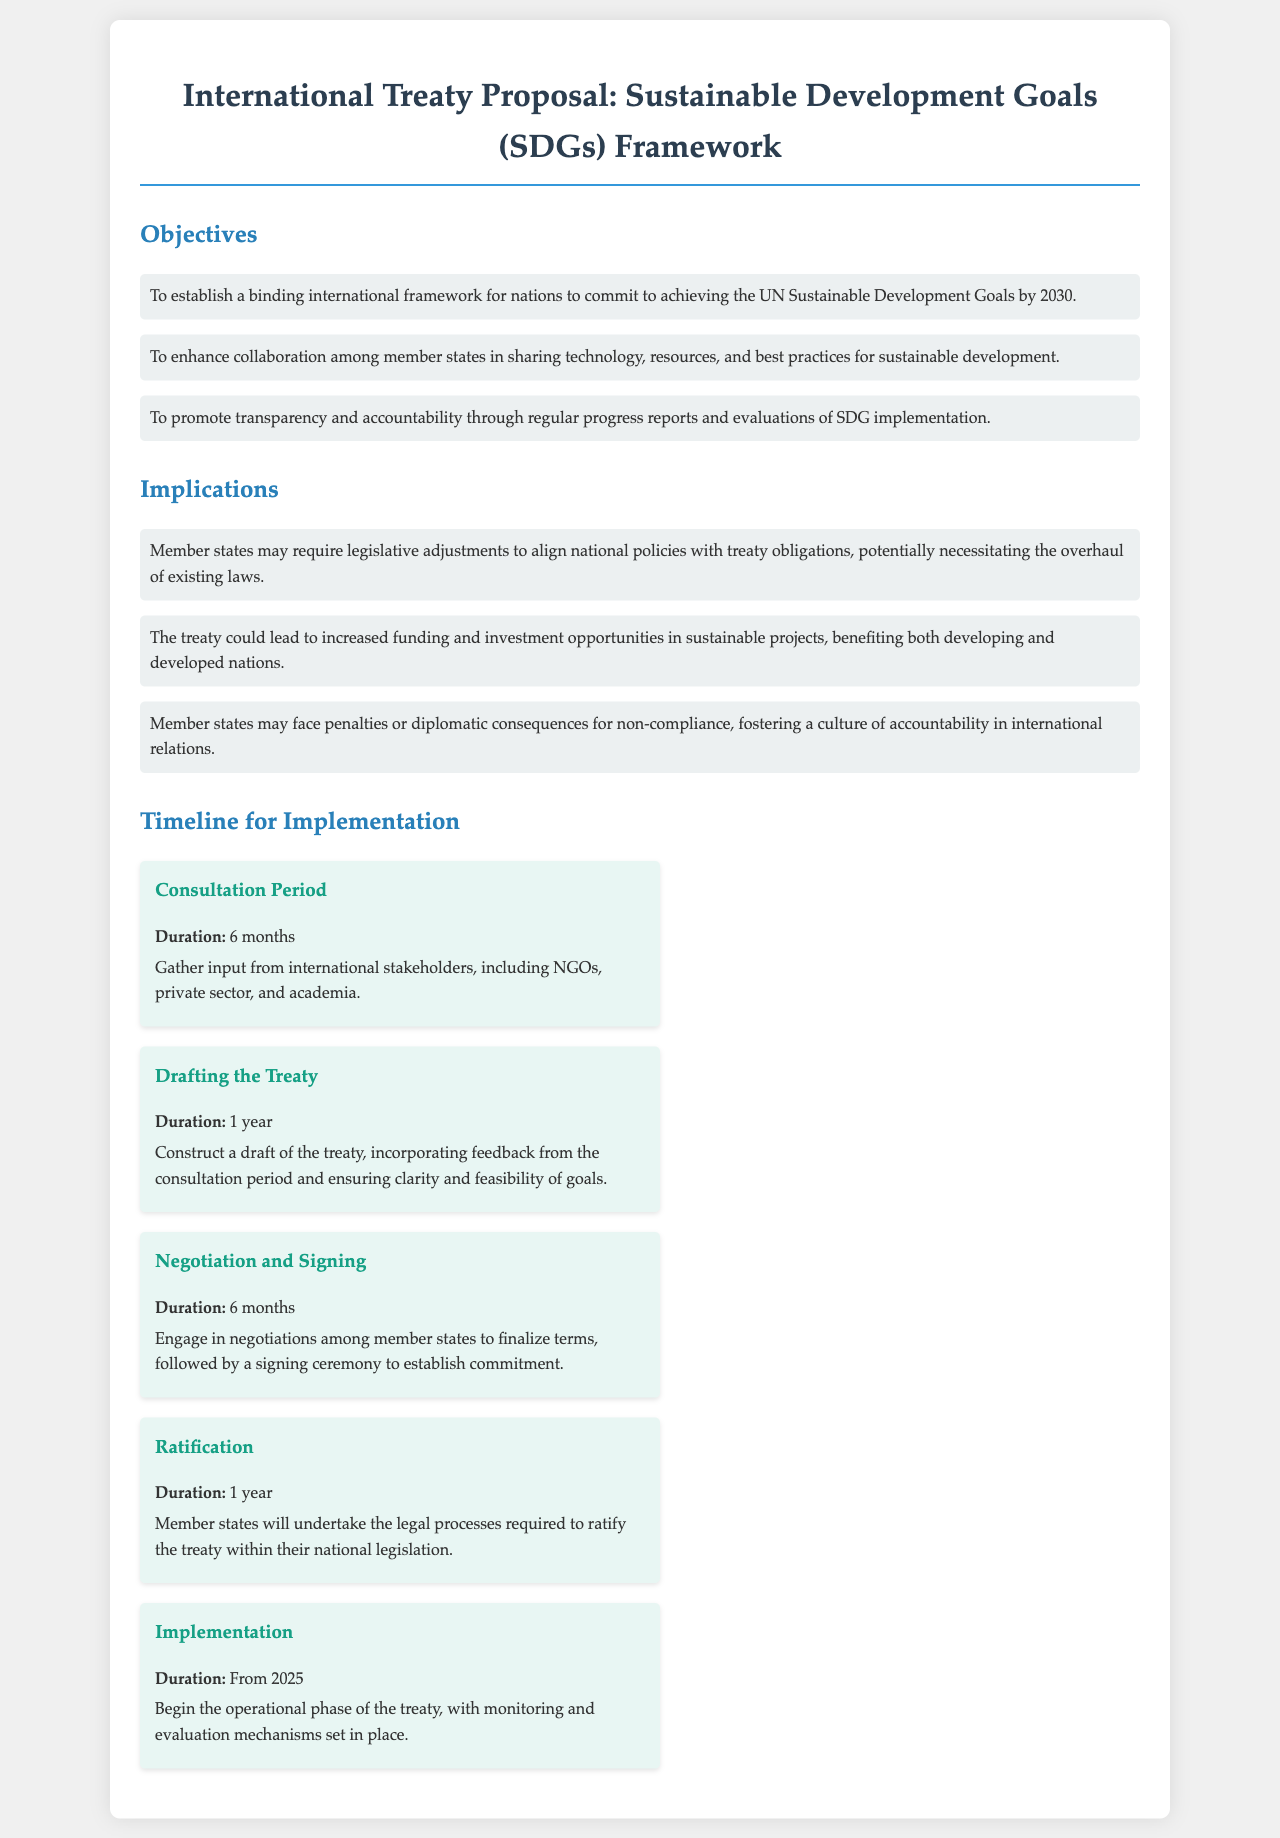What are the main goals of the treaty? The document outlines the objectives of the treaty, which include establishing a binding framework, enhancing collaboration, and promoting transparency.
Answer: To establish a binding international framework for nations to commit to achieving the UN Sustainable Development Goals by 2030 What is the duration of the Consultation Period? The document specifies the duration for each phase of implementation, including the Consultation Period.
Answer: 6 months How long is the Drafting the Treaty phase? This phase's duration is noted in the timeline section of the document.
Answer: 1 year What financial opportunities might arise from the treaty? The implications section mentions the potential for increased funding and investment in sustainable projects.
Answer: Increased funding and investment opportunities When will the Implementation phase begin? The timeline clearly states the starting year for the operational phase of the treaty.
Answer: From 2025 What is one potential consequence of non-compliance with the treaty? The implications section discusses possible diplomatic consequences as a result of non-compliance.
Answer: Diplomatic consequences How many phases are outlined in the implementation timeline? The timeline details several distinct phases, each accompanied by its own duration.
Answer: 5 phases What is the focus of the treaty? The title of the document indicates the primary focus area of the treaty.
Answer: Sustainable Development Goals (SDGs) Framework 